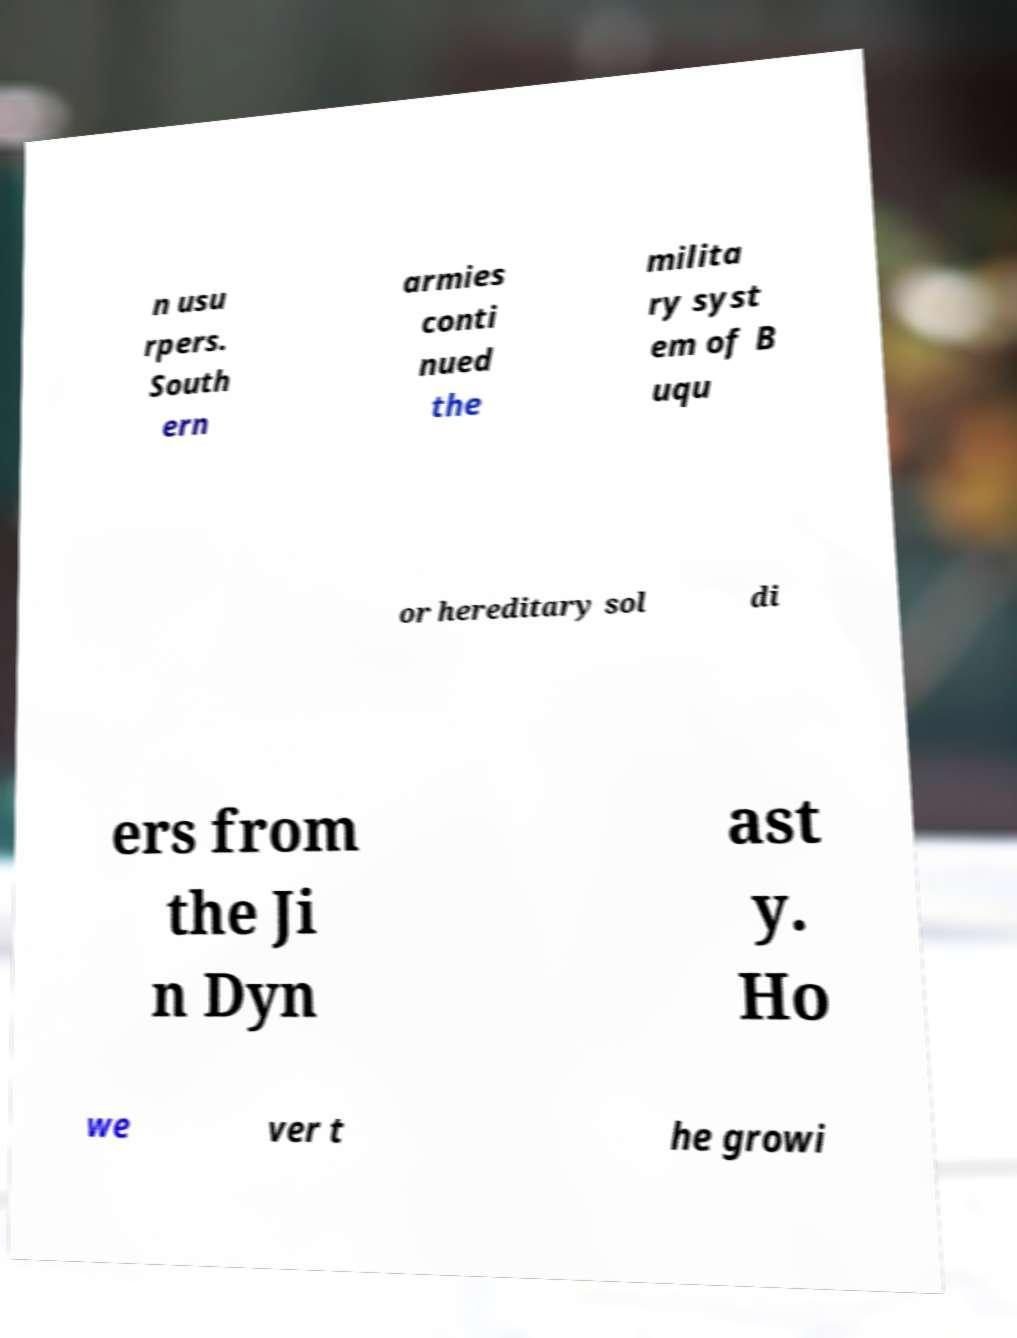Could you assist in decoding the text presented in this image and type it out clearly? n usu rpers. South ern armies conti nued the milita ry syst em of B uqu or hereditary sol di ers from the Ji n Dyn ast y. Ho we ver t he growi 